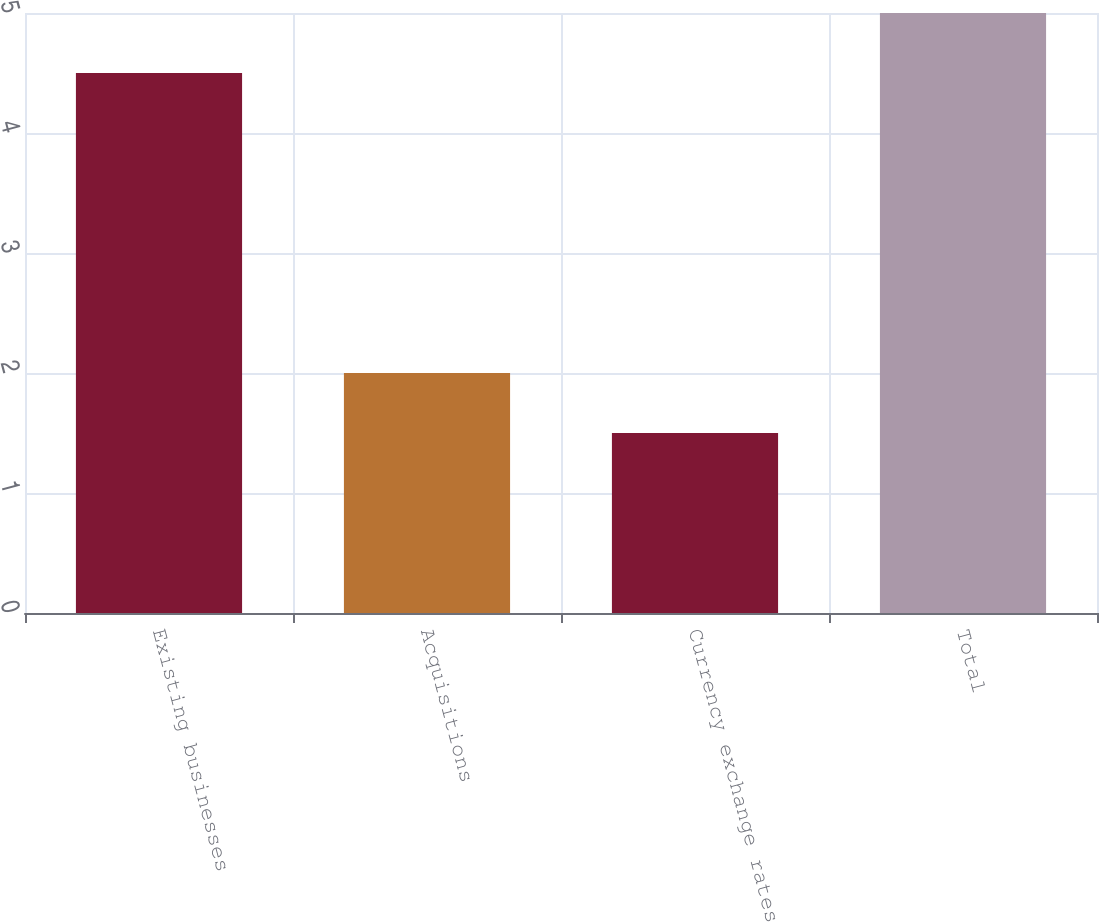Convert chart. <chart><loc_0><loc_0><loc_500><loc_500><bar_chart><fcel>Existing businesses<fcel>Acquisitions<fcel>Currency exchange rates<fcel>Total<nl><fcel>4.5<fcel>2<fcel>1.5<fcel>5<nl></chart> 